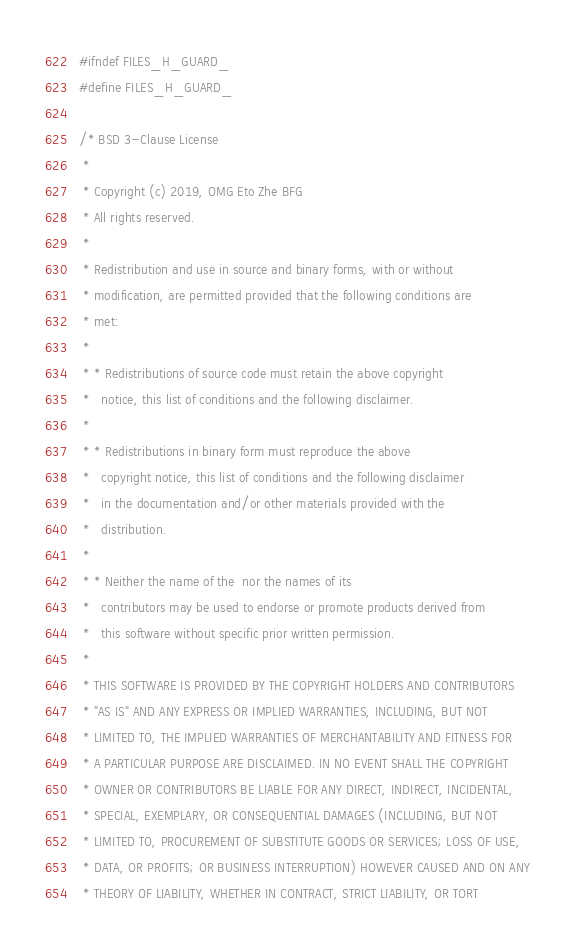<code> <loc_0><loc_0><loc_500><loc_500><_C_>#ifndef FILES_H_GUARD_
#define FILES_H_GUARD_

/* BSD 3-Clause License
 *
 * Copyright (c) 2019, OMG Eto Zhe BFG
 * All rights reserved.
 *
 * Redistribution and use in source and binary forms, with or without
 * modification, are permitted provided that the following conditions are
 * met:
 *
 * * Redistributions of source code must retain the above copyright
 *   notice, this list of conditions and the following disclaimer.
 *
 * * Redistributions in binary form must reproduce the above
 *   copyright notice, this list of conditions and the following disclaimer
 *   in the documentation and/or other materials provided with the
 *   distribution.
 *
 * * Neither the name of the  nor the names of its
 *   contributors may be used to endorse or promote products derived from
 *   this software without specific prior written permission.
 *
 * THIS SOFTWARE IS PROVIDED BY THE COPYRIGHT HOLDERS AND CONTRIBUTORS
 * "AS IS" AND ANY EXPRESS OR IMPLIED WARRANTIES, INCLUDING, BUT NOT
 * LIMITED TO, THE IMPLIED WARRANTIES OF MERCHANTABILITY AND FITNESS FOR
 * A PARTICULAR PURPOSE ARE DISCLAIMED. IN NO EVENT SHALL THE COPYRIGHT
 * OWNER OR CONTRIBUTORS BE LIABLE FOR ANY DIRECT, INDIRECT, INCIDENTAL,
 * SPECIAL, EXEMPLARY, OR CONSEQUENTIAL DAMAGES (INCLUDING, BUT NOT
 * LIMITED TO, PROCUREMENT OF SUBSTITUTE GOODS OR SERVICES; LOSS OF USE,
 * DATA, OR PROFITS; OR BUSINESS INTERRUPTION) HOWEVER CAUSED AND ON ANY
 * THEORY OF LIABILITY, WHETHER IN CONTRACT, STRICT LIABILITY, OR TORT</code> 